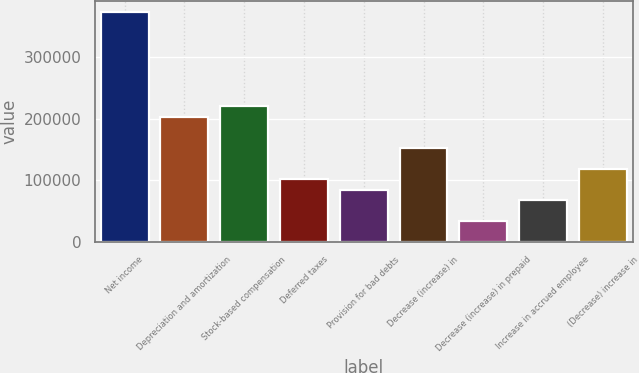<chart> <loc_0><loc_0><loc_500><loc_500><bar_chart><fcel>Net income<fcel>Depreciation and amortization<fcel>Stock-based compensation<fcel>Deferred taxes<fcel>Provision for bad debts<fcel>Decrease (increase) in<fcel>Decrease (increase) in prepaid<fcel>Increase in accrued employee<fcel>(Decrease) increase in<nl><fcel>373112<fcel>203535<fcel>220493<fcel>101789<fcel>84831.5<fcel>152662<fcel>33958.4<fcel>67873.8<fcel>118747<nl></chart> 